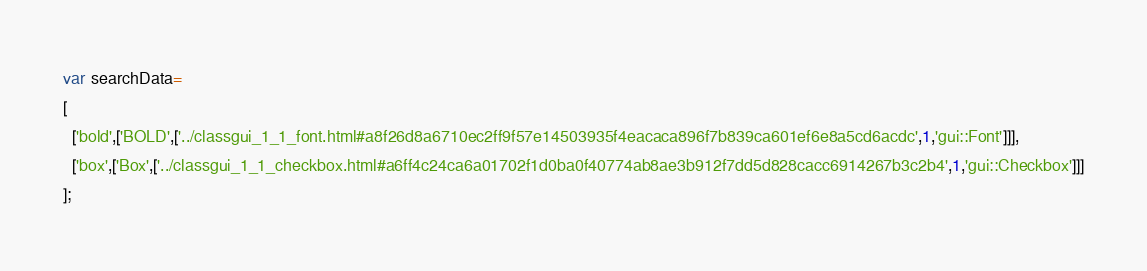Convert code to text. <code><loc_0><loc_0><loc_500><loc_500><_JavaScript_>var searchData=
[
  ['bold',['BOLD',['../classgui_1_1_font.html#a8f26d8a6710ec2ff9f57e14503935f4eacaca896f7b839ca601ef6e8a5cd6acdc',1,'gui::Font']]],
  ['box',['Box',['../classgui_1_1_checkbox.html#a6ff4c24ca6a01702f1d0ba0f40774ab8ae3b912f7dd5d828cacc6914267b3c2b4',1,'gui::Checkbox']]]
];
</code> 